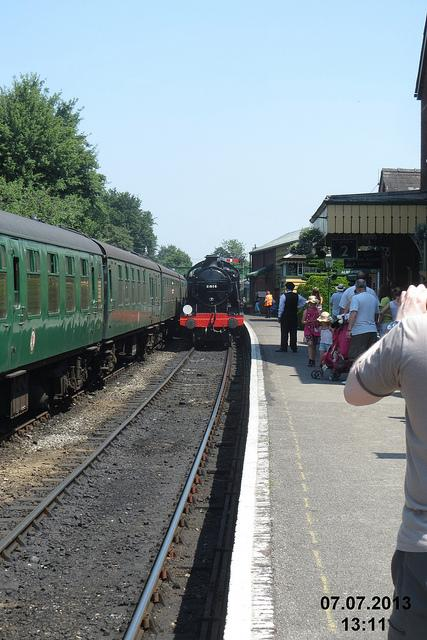How many days after the Independence Day was this picture taken? three 